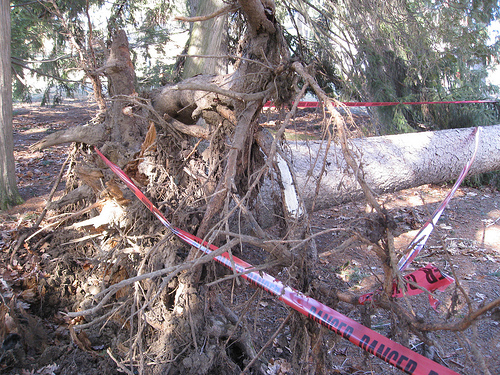<image>
Is there a tape on the tree? Yes. Looking at the image, I can see the tape is positioned on top of the tree, with the tree providing support. 